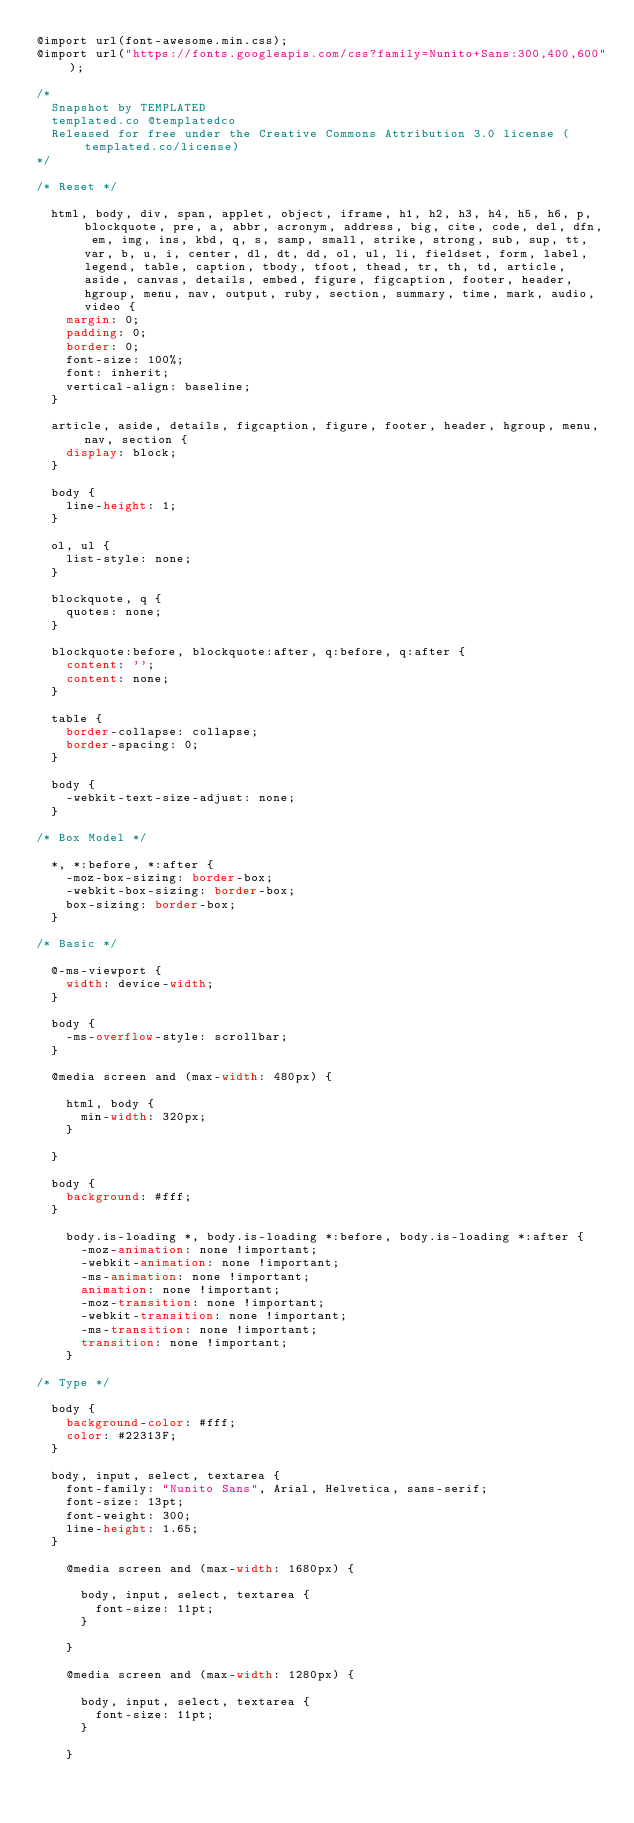Convert code to text. <code><loc_0><loc_0><loc_500><loc_500><_CSS_>@import url(font-awesome.min.css);
@import url("https://fonts.googleapis.com/css?family=Nunito+Sans:300,400,600");

/*
	Snapshot by TEMPLATED
	templated.co @templatedco
	Released for free under the Creative Commons Attribution 3.0 license (templated.co/license)
*/

/* Reset */

	html, body, div, span, applet, object, iframe, h1, h2, h3, h4, h5, h6, p, blockquote, pre, a, abbr, acronym, address, big, cite, code, del, dfn, em, img, ins, kbd, q, s, samp, small, strike, strong, sub, sup, tt, var, b, u, i, center, dl, dt, dd, ol, ul, li, fieldset, form, label, legend, table, caption, tbody, tfoot, thead, tr, th, td, article, aside, canvas, details, embed, figure, figcaption, footer, header, hgroup, menu, nav, output, ruby, section, summary, time, mark, audio, video {
		margin: 0;
		padding: 0;
		border: 0;
		font-size: 100%;
		font: inherit;
		vertical-align: baseline;
	}

	article, aside, details, figcaption, figure, footer, header, hgroup, menu, nav, section {
		display: block;
	}

	body {
		line-height: 1;
	}

	ol, ul {
		list-style: none;
	}

	blockquote, q {
		quotes: none;
	}

	blockquote:before, blockquote:after, q:before, q:after {
		content: '';
		content: none;
	}

	table {
		border-collapse: collapse;
		border-spacing: 0;
	}

	body {
		-webkit-text-size-adjust: none;
	}

/* Box Model */

	*, *:before, *:after {
		-moz-box-sizing: border-box;
		-webkit-box-sizing: border-box;
		box-sizing: border-box;
	}

/* Basic */

	@-ms-viewport {
		width: device-width;
	}

	body {
		-ms-overflow-style: scrollbar;
	}

	@media screen and (max-width: 480px) {

		html, body {
			min-width: 320px;
		}

	}

	body {
		background: #fff;
	}

		body.is-loading *, body.is-loading *:before, body.is-loading *:after {
			-moz-animation: none !important;
			-webkit-animation: none !important;
			-ms-animation: none !important;
			animation: none !important;
			-moz-transition: none !important;
			-webkit-transition: none !important;
			-ms-transition: none !important;
			transition: none !important;
		}

/* Type */

	body {
		background-color: #fff;
		color: #22313F;
	}

	body, input, select, textarea {
		font-family: "Nunito Sans", Arial, Helvetica, sans-serif;
		font-size: 13pt;
		font-weight: 300;
		line-height: 1.65;
	}

		@media screen and (max-width: 1680px) {

			body, input, select, textarea {
				font-size: 11pt;
			}

		}

		@media screen and (max-width: 1280px) {

			body, input, select, textarea {
				font-size: 11pt;
			}

		}
</code> 